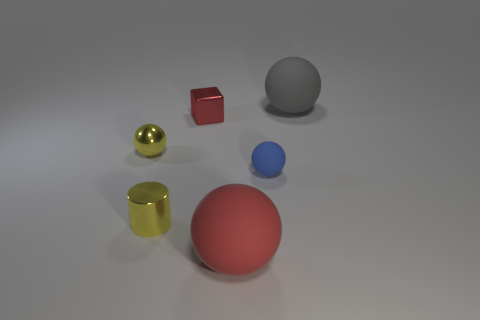How many gray rubber things are there?
Ensure brevity in your answer.  1. What material is the red object to the right of the red shiny thing that is on the left side of the big gray object?
Offer a terse response. Rubber. What is the material of the yellow thing that is the same size as the yellow shiny cylinder?
Keep it short and to the point. Metal. Do the yellow cylinder left of the blue object and the red rubber thing have the same size?
Your response must be concise. No. There is a big thing in front of the gray sphere; does it have the same shape as the tiny blue thing?
Your answer should be very brief. Yes. How many things are gray matte objects or objects in front of the large gray thing?
Ensure brevity in your answer.  6. Are there fewer yellow metallic cylinders than cyan spheres?
Keep it short and to the point. No. Is the number of red cubes greater than the number of spheres?
Offer a terse response. No. How many other things are the same material as the large red ball?
Give a very brief answer. 2. There is a rubber sphere that is behind the sphere that is to the left of the red shiny thing; how many gray matte spheres are to the right of it?
Offer a very short reply. 0. 